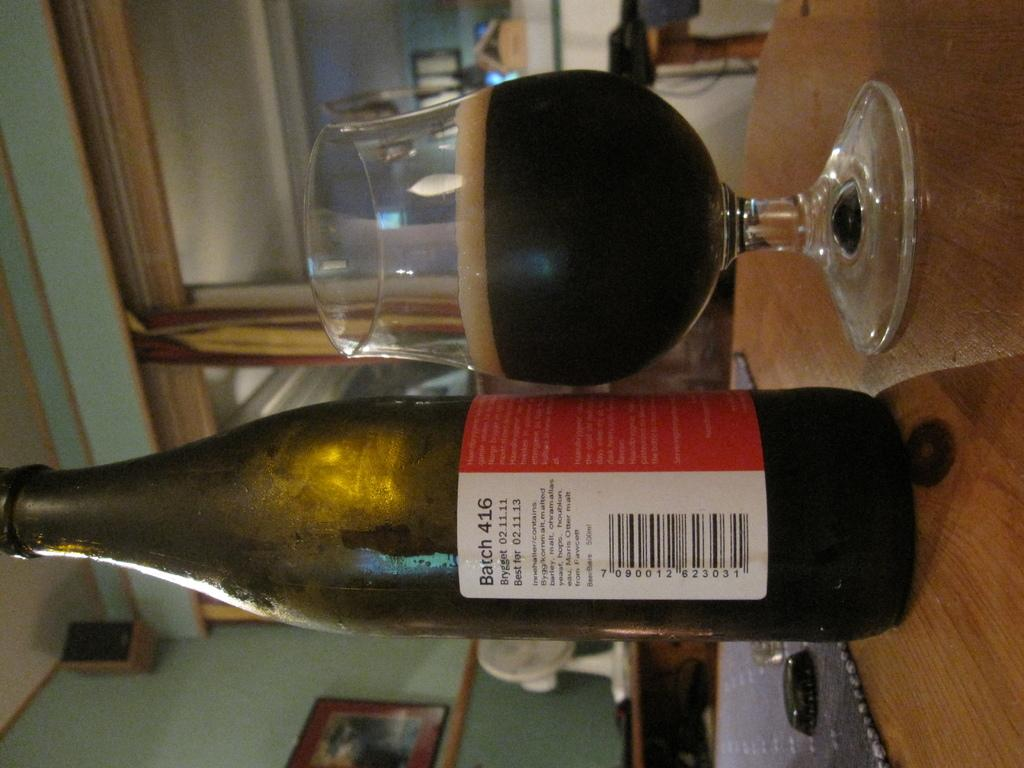Provide a one-sentence caption for the provided image. A beer bottle that says Barch 416 placed next to a beer glass. 